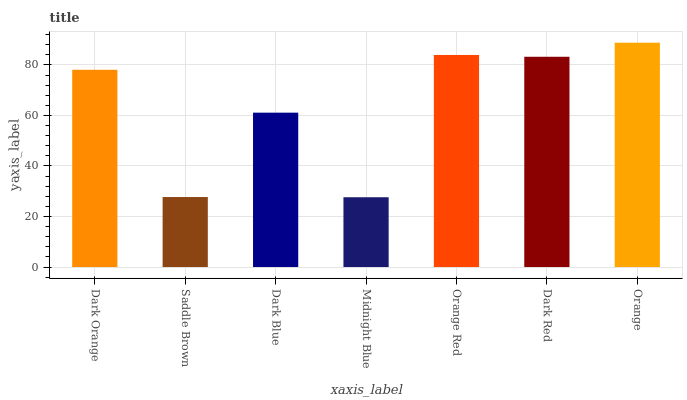Is Midnight Blue the minimum?
Answer yes or no. Yes. Is Orange the maximum?
Answer yes or no. Yes. Is Saddle Brown the minimum?
Answer yes or no. No. Is Saddle Brown the maximum?
Answer yes or no. No. Is Dark Orange greater than Saddle Brown?
Answer yes or no. Yes. Is Saddle Brown less than Dark Orange?
Answer yes or no. Yes. Is Saddle Brown greater than Dark Orange?
Answer yes or no. No. Is Dark Orange less than Saddle Brown?
Answer yes or no. No. Is Dark Orange the high median?
Answer yes or no. Yes. Is Dark Orange the low median?
Answer yes or no. Yes. Is Midnight Blue the high median?
Answer yes or no. No. Is Orange the low median?
Answer yes or no. No. 